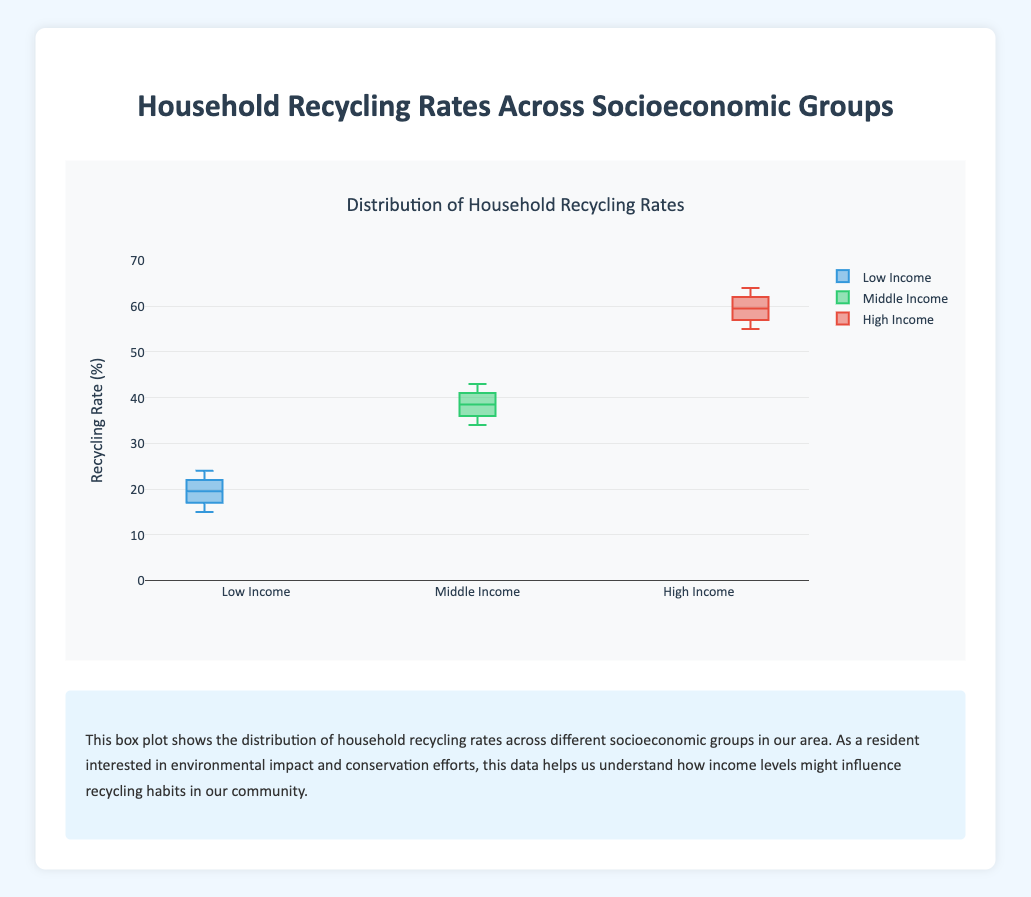What is the title of the figure? The title is located at the top of the plot. It gives an overall description of the plot's subject.
Answer: Distribution of Household Recycling Rates What does the y-axis represent? The y-axis is labeled with "Recycling Rate (%)", indicating that it represents the recycling rates as percentages.
Answer: Recycling Rate (%) What is the color used to represent the "High Income" group's data? By observing the legend and the color associated with "High Income", you can see that it uses a red color.
Answer: Red Which socioeconomic group has the highest median recycling rate? Inspecting the line inside each box, which denotes the median, the "High Income" group has the highest line.
Answer: High Income Are there any outliers in the Low Income group's recycling rates? Outliers in a box plot are marked with individual points outside the "whiskers". The Low Income group's data does not have any points outside the whiskers.
Answer: No What is the interquartile range (IQR) for the Middle Income group? The IQR is the difference between the third quartile (Q3) and the first quartile (Q1). From the plot, Q3 is around 41 and Q1 is around 36 for the Middle Income group.
Answer: 5 What is the maximum value for the High Income group's recycling rates? In a box plot, the maximum value is represented by the top end of the whisker. For the High Income group, this value is 64%.
Answer: 64% Compare the median recycling rates of the Low Income and Middle Income groups. The median is represented by the line within the box. The Low Income group has a median of around 20%, while the Middle Income group has a median of around 38%.
Answer: Middle Income is higher Which group shows the greatest variability in recycling rates? Variability can be assessed by the range between the minimum and maximum values or by the spread of the box. The High Income group has the widest spread.
Answer: High Income 